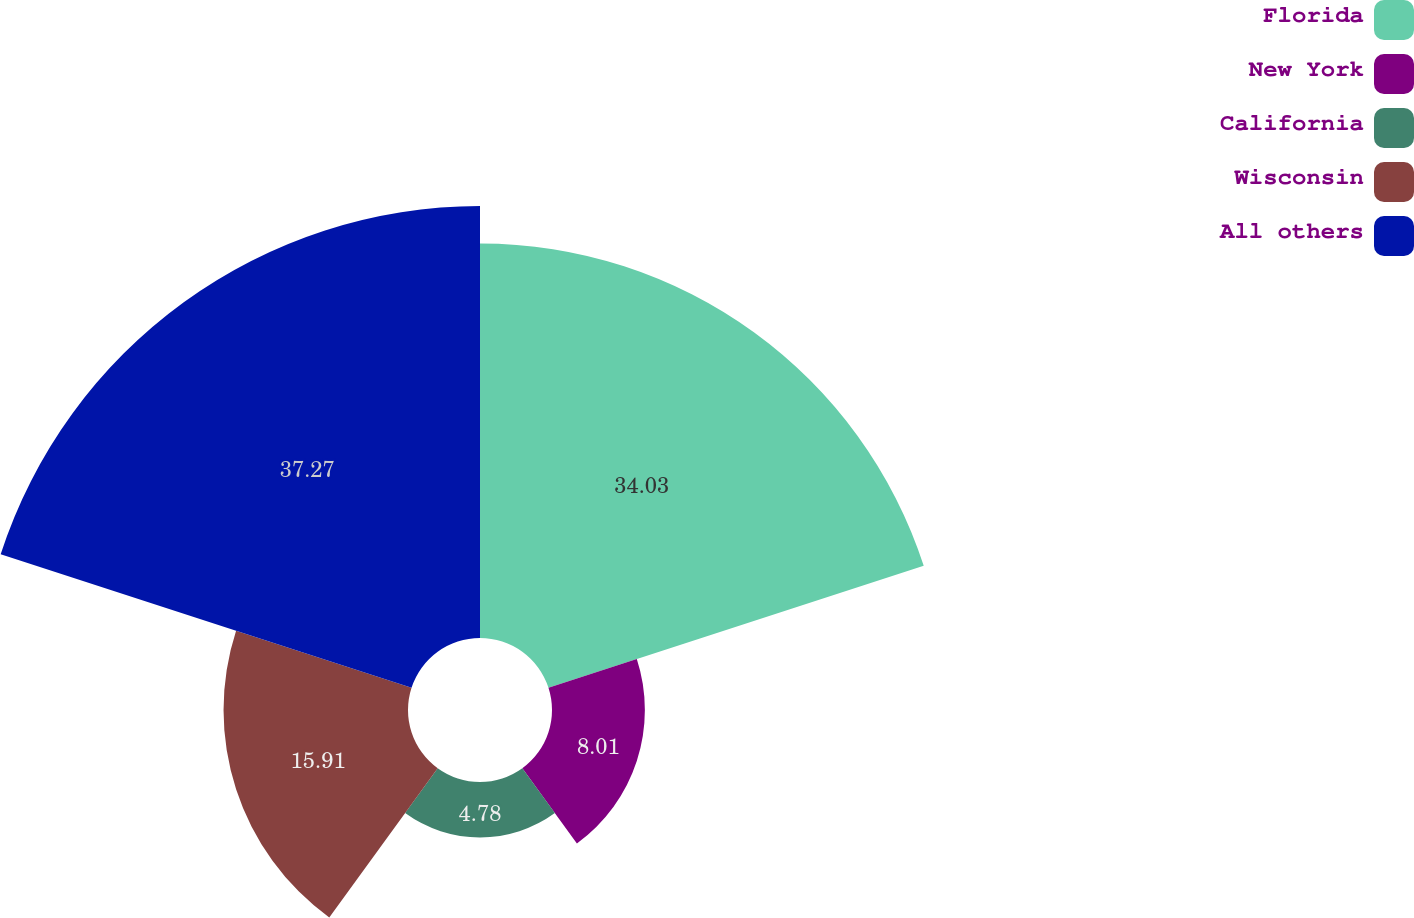Convert chart to OTSL. <chart><loc_0><loc_0><loc_500><loc_500><pie_chart><fcel>Florida<fcel>New York<fcel>California<fcel>Wisconsin<fcel>All others<nl><fcel>34.03%<fcel>8.01%<fcel>4.78%<fcel>15.91%<fcel>37.26%<nl></chart> 